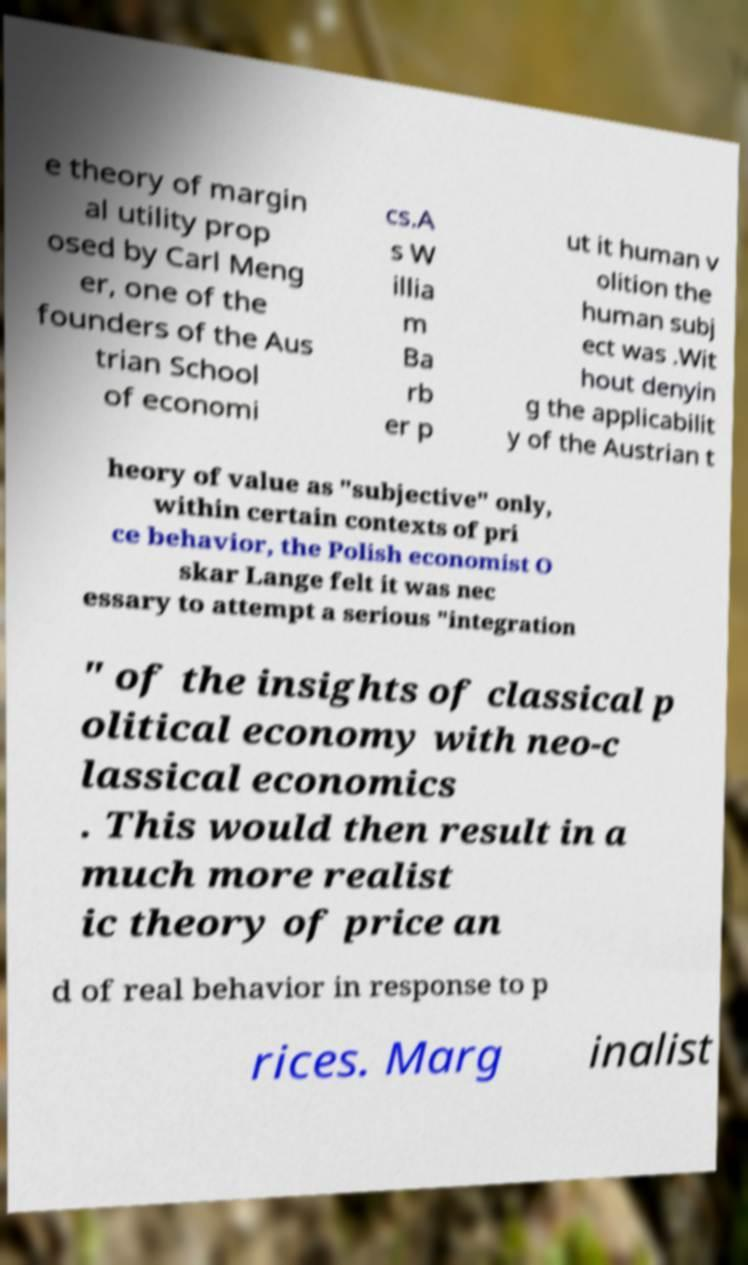Can you read and provide the text displayed in the image?This photo seems to have some interesting text. Can you extract and type it out for me? e theory of margin al utility prop osed by Carl Meng er, one of the founders of the Aus trian School of economi cs.A s W illia m Ba rb er p ut it human v olition the human subj ect was .Wit hout denyin g the applicabilit y of the Austrian t heory of value as "subjective" only, within certain contexts of pri ce behavior, the Polish economist O skar Lange felt it was nec essary to attempt a serious "integration " of the insights of classical p olitical economy with neo-c lassical economics . This would then result in a much more realist ic theory of price an d of real behavior in response to p rices. Marg inalist 